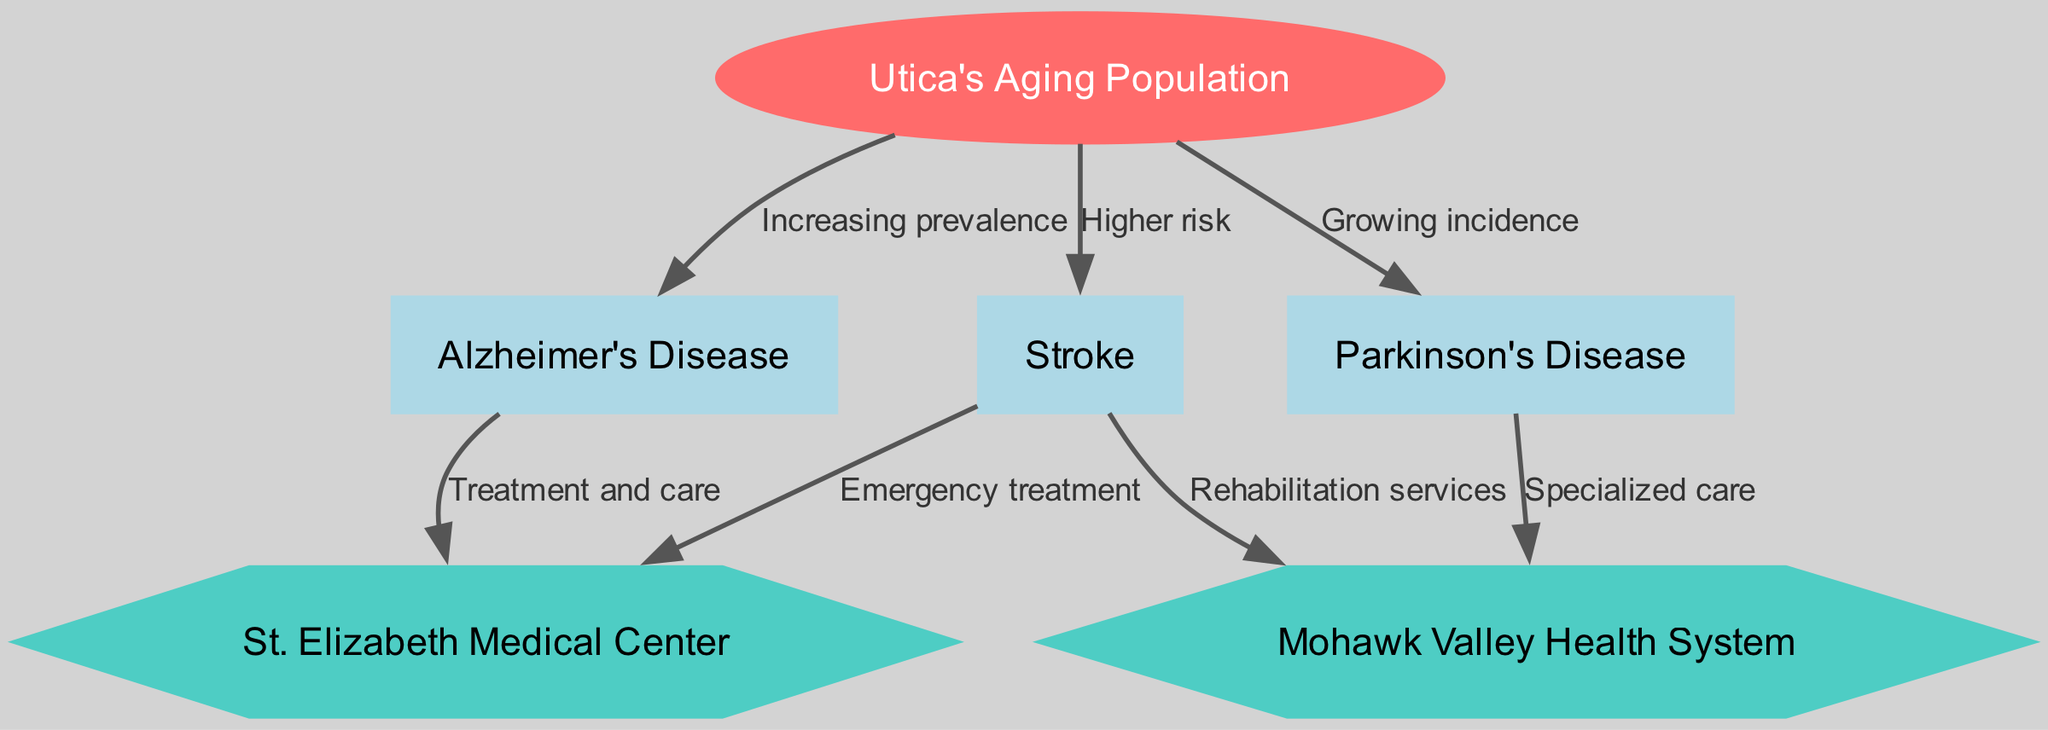What is the main health concern identified for Utica's aging population? The diagram connects "Utica's Aging Population" to the three neurological disorders listed: Alzheimer's Disease, Parkinson's Disease, and Stroke. Among these, Alzheimer's Disease is noted for "Increasing prevalence," making it the main health concern.
Answer: Alzheimer's Disease How many nodes are present in the diagram? By reviewing the diagram, we can count the nodes: 1 (Utica's Aging Population) + 3 (Alzheimer's Disease, Parkinson's Disease, Stroke) + 2 (St. Elizabeth Medical Center, Mohawk Valley Health System) results in a total of 6 nodes.
Answer: 6 What type of care is linked to Alzheimer's Disease? The diagram shows a connection from "Alzheimer's Disease" to "St. Elizabeth Medical Center" labeled as "Treatment and care," indicating this type of care is specifically linked to Alzheimer's Disease.
Answer: Treatment and care Which healthcare facility is associated with specialized care for Parkinson's Disease? The edge from "Parkinson's Disease" to "Mohawk Valley Health System" indicates that this facility is involved in providing specialized care for Parkinson’s Disease.
Answer: Mohawk Valley Health System What is the relationship between Stroke and the services provided at St. Elizabeth Medical Center? The diagram links "Stroke" to "St. Elizabeth Medical Center" with an edge labeled "Emergency treatment," indicating that the relationship involves urgent care services for stroke patients at this facility.
Answer: Emergency treatment How does the aging population affect the incidence of Parkinson's Disease? The diagram connects "Utica's Aging Population" to "Parkinson's Disease," noting "Growing incidence." This relationship indicates that as the population ages, the incidence of Parkinson's Disease increases.
Answer: Growing incidence How many types of care are provided in relation to Stroke? There are two connections related to Stroke: one to "St. Elizabeth Medical Center" for "Emergency treatment" and one to "Mohawk Valley Health System" for "Rehabilitation services." Thus, there are two types of care associated with Stroke in the diagram.
Answer: 2 What does the diagram indicate about the trend of neurological disorders among the aging population? The connections from "Utica's Aging Population" to the three disorders highlight a trend of increasing prevalence, growing incidence, and higher risk of neurological disorders as this population ages, indicating a concerning demographic shift.
Answer: Increasing prevalence, growing incidence, higher risk 